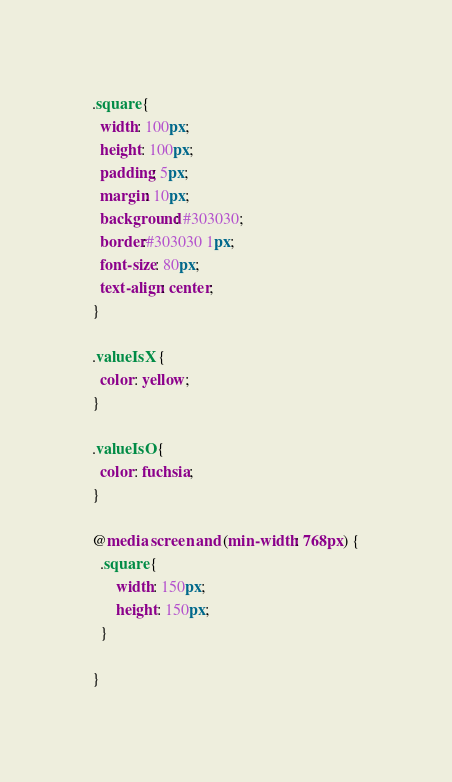<code> <loc_0><loc_0><loc_500><loc_500><_CSS_>.square {
  width: 100px;
  height: 100px;
  padding: 5px;
  margin: 10px;
  background: #303030;
  border:#303030 1px;
  font-size: 80px;
  text-align: center;
}

.valueIsX {
  color: yellow;
}

.valueIsO {
  color: fuchsia;
}

@media screen and (min-width: 768px) {
  .square {
      width: 150px;
      height: 150px;
  }

}

</code> 